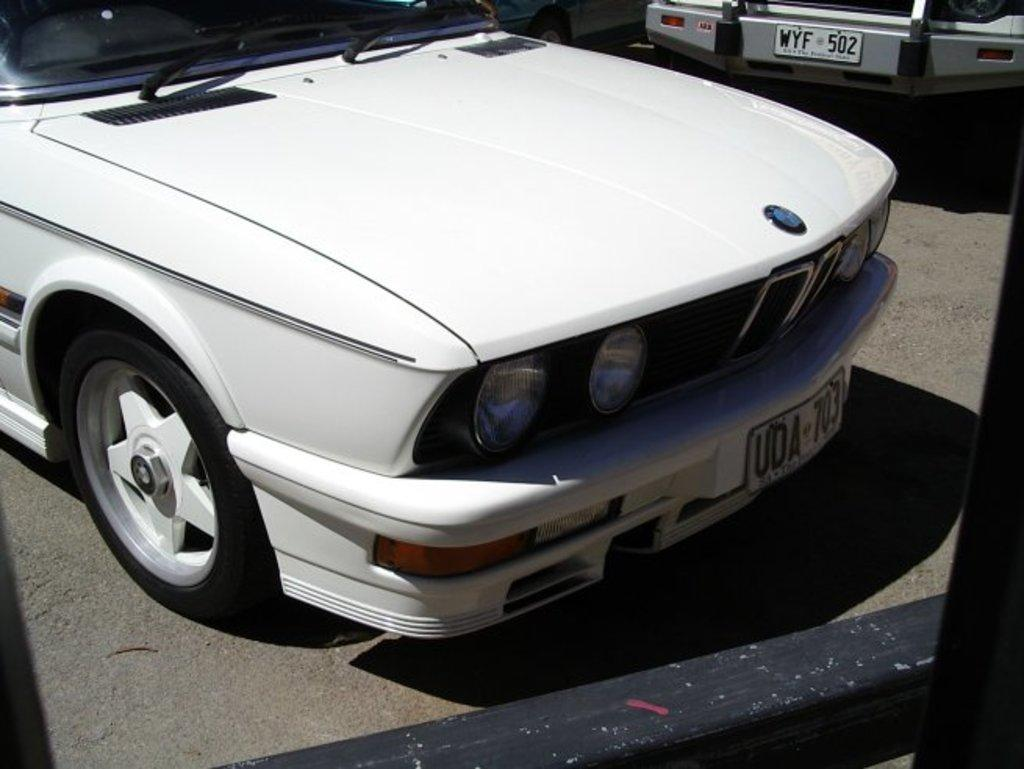What color is the car that is the main subject of the image? The car that is the main subject of the image is white. Where is the white car located in the image? The white car is on the road. Are there any other cars visible in the image? Yes, there is another car visible in the top right of the image. What word is written on the side of the white car in the image? There is no word written on the side of the white car in the image. Can you see any insects crawling on the white car in the image? There are no insects visible on the white car in the image. 